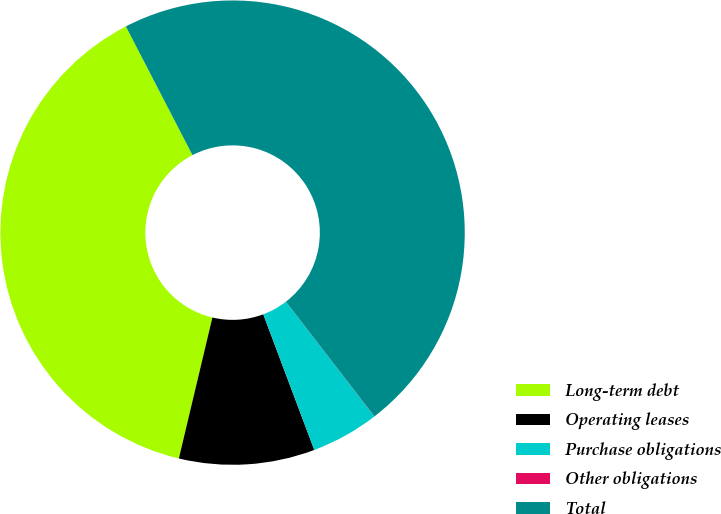<chart> <loc_0><loc_0><loc_500><loc_500><pie_chart><fcel>Long-term debt<fcel>Operating leases<fcel>Purchase obligations<fcel>Other obligations<fcel>Total<nl><fcel>38.68%<fcel>9.44%<fcel>4.73%<fcel>0.01%<fcel>47.14%<nl></chart> 